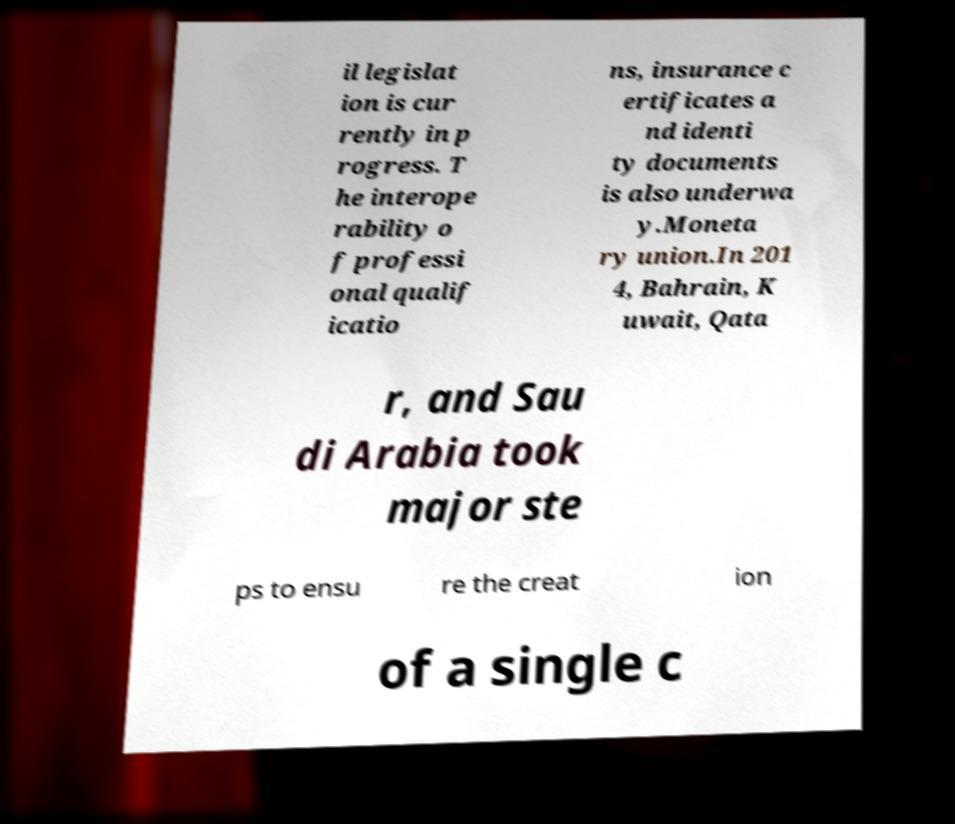For documentation purposes, I need the text within this image transcribed. Could you provide that? il legislat ion is cur rently in p rogress. T he interope rability o f professi onal qualif icatio ns, insurance c ertificates a nd identi ty documents is also underwa y.Moneta ry union.In 201 4, Bahrain, K uwait, Qata r, and Sau di Arabia took major ste ps to ensu re the creat ion of a single c 